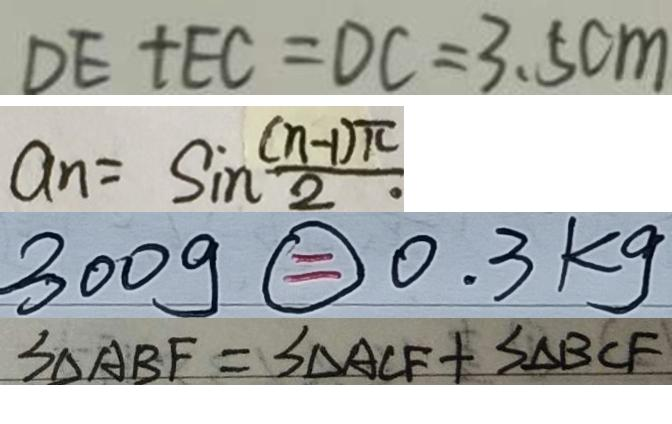Convert formula to latex. <formula><loc_0><loc_0><loc_500><loc_500>D E + E C = D C = 3 . 5 c m 
 a _ { n } = \sin \frac { ( n - 1 ) \pi } { 2 } 
 3 0 0 g \textcircled { = } 0 . 3 k g 
 S _ { \Delta A B F } = S _ { \Delta A C F } + S _ { \Delta B C F }</formula> 